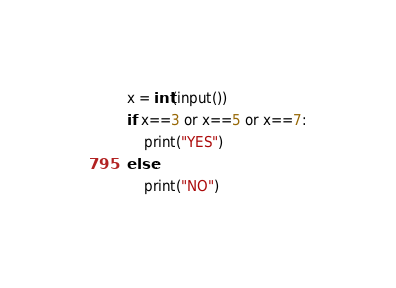<code> <loc_0><loc_0><loc_500><loc_500><_Java_>x = int(input())
if x==3 or x==5 or x==7:
    print("YES")
else:
    print("NO")</code> 